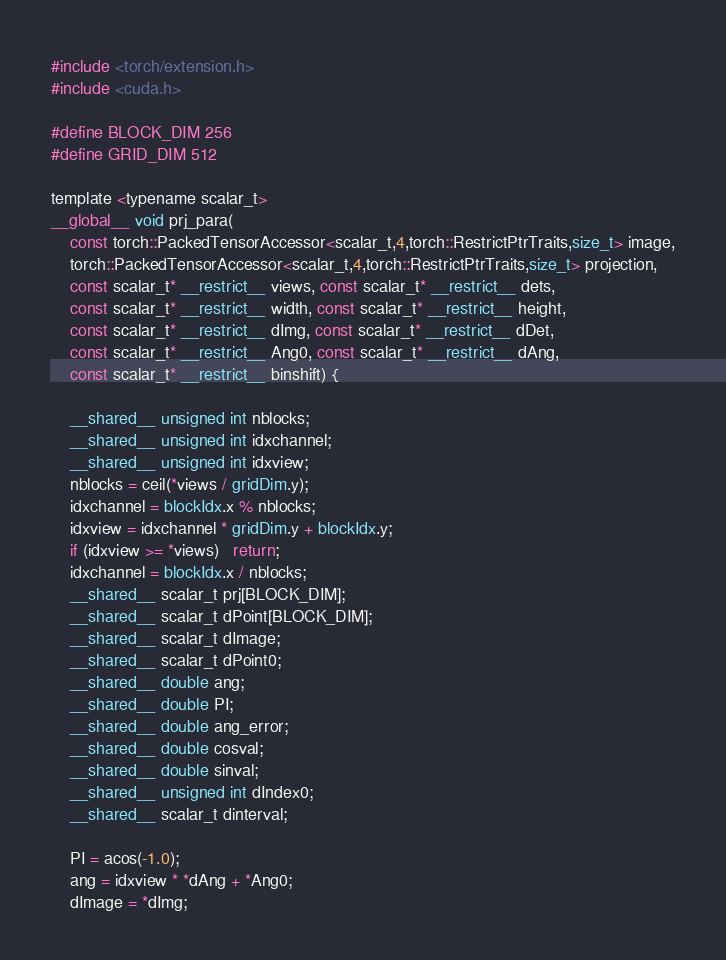<code> <loc_0><loc_0><loc_500><loc_500><_Cuda_>#include <torch/extension.h>
#include <cuda.h>

#define BLOCK_DIM 256
#define GRID_DIM 512

template <typename scalar_t>
__global__ void prj_para(
    const torch::PackedTensorAccessor<scalar_t,4,torch::RestrictPtrTraits,size_t> image,
    torch::PackedTensorAccessor<scalar_t,4,torch::RestrictPtrTraits,size_t> projection,
    const scalar_t* __restrict__ views, const scalar_t* __restrict__ dets,
    const scalar_t* __restrict__ width, const scalar_t* __restrict__ height,
    const scalar_t* __restrict__ dImg, const scalar_t* __restrict__ dDet,
    const scalar_t* __restrict__ Ang0, const scalar_t* __restrict__ dAng, 
    const scalar_t* __restrict__ binshift) {
    
    __shared__ unsigned int nblocks;
    __shared__ unsigned int idxchannel;
    __shared__ unsigned int idxview;
    nblocks = ceil(*views / gridDim.y);
    idxchannel = blockIdx.x % nblocks;
    idxview = idxchannel * gridDim.y + blockIdx.y;
    if (idxview >= *views)   return;
    idxchannel = blockIdx.x / nblocks;
    __shared__ scalar_t prj[BLOCK_DIM];
    __shared__ scalar_t dPoint[BLOCK_DIM];
    __shared__ scalar_t dImage;
    __shared__ scalar_t dPoint0;
    __shared__ double ang;
    __shared__ double PI;
    __shared__ double ang_error;
    __shared__ double cosval;
    __shared__ double sinval;
    __shared__ unsigned int dIndex0;
    __shared__ scalar_t dinterval;

    PI = acos(-1.0);
    ang = idxview * *dAng + *Ang0;
    dImage = *dImg;</code> 